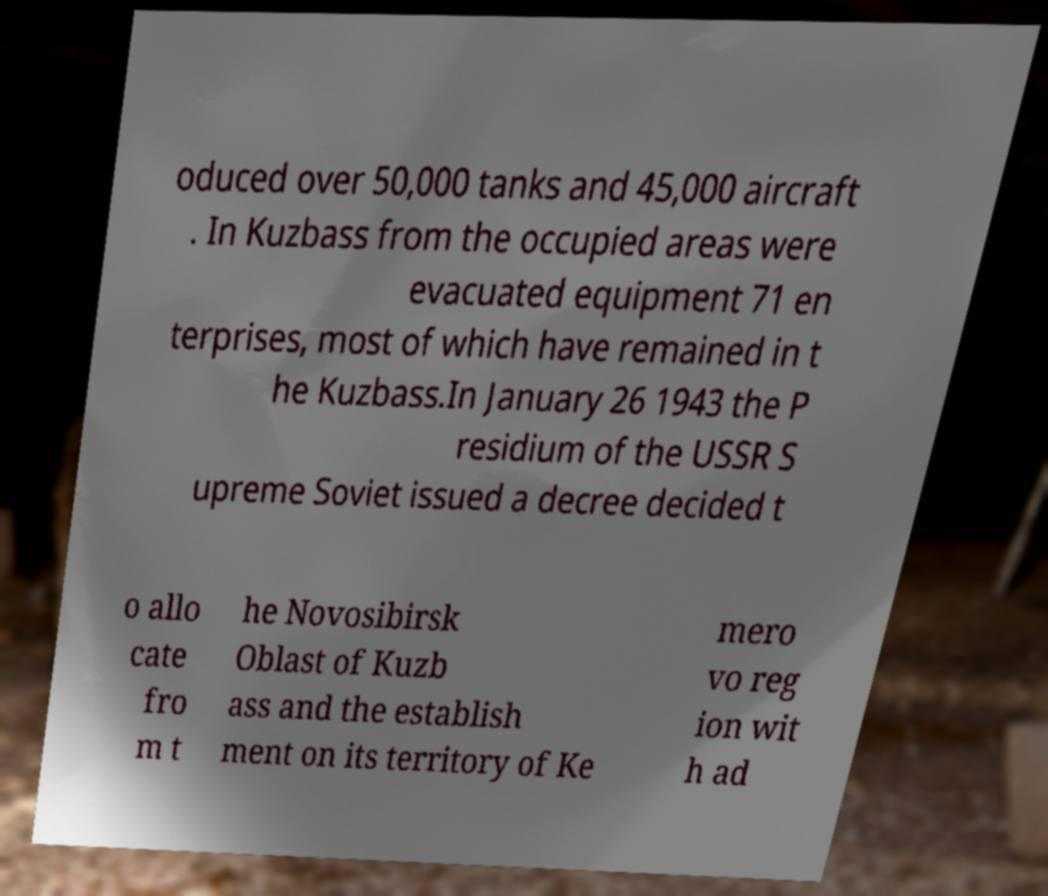Can you accurately transcribe the text from the provided image for me? oduced over 50,000 tanks and 45,000 aircraft . In Kuzbass from the occupied areas were evacuated equipment 71 en terprises, most of which have remained in t he Kuzbass.In January 26 1943 the P residium of the USSR S upreme Soviet issued a decree decided t o allo cate fro m t he Novosibirsk Oblast of Kuzb ass and the establish ment on its territory of Ke mero vo reg ion wit h ad 